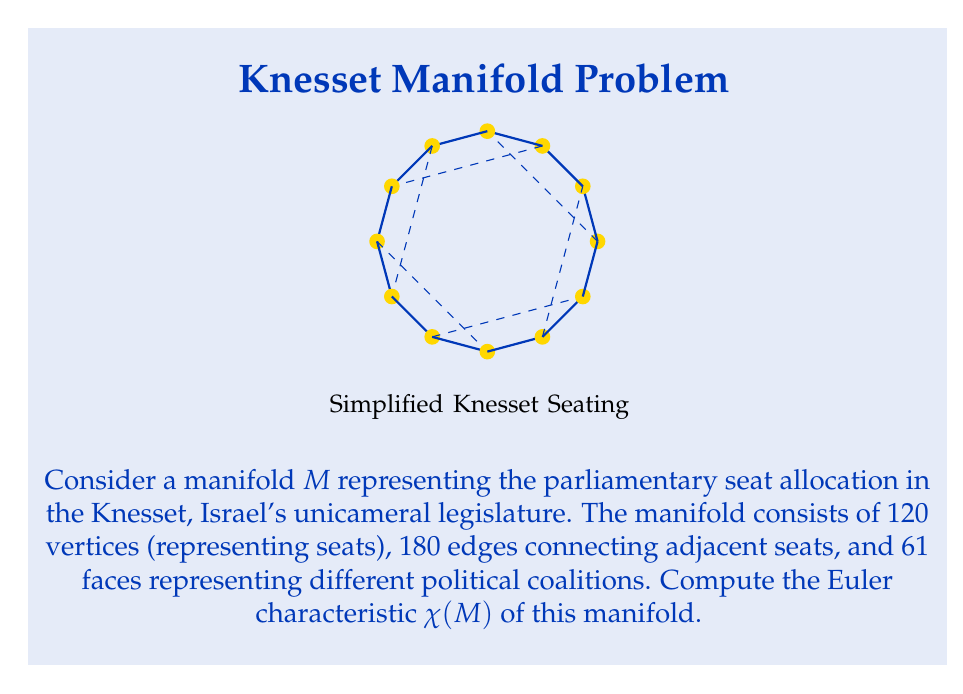Could you help me with this problem? To compute the Euler characteristic of the manifold $M$, we use the formula:

$$\chi(M) = V - E + F$$

Where:
$V$ = number of vertices
$E$ = number of edges
$F$ = number of faces

Given:
- $V = 120$ (seats in the Knesset)
- $E = 180$ (connections between adjacent seats)
- $F = 61$ (political coalitions)

Let's substitute these values into the formula:

$$\begin{align}
\chi(M) &= V - E + F \\
&= 120 - 180 + 61 \\
&= 1
\end{align}$$

Therefore, the Euler characteristic of the manifold representing the Knesset seat allocation is 1.

This result is interesting in the context of Israeli politics, as it suggests that despite the complex interconnections and coalitions, the overall structure of the parliament maintains a simple topological nature, similar to that of a sphere or a plane.
Answer: $\chi(M) = 1$ 